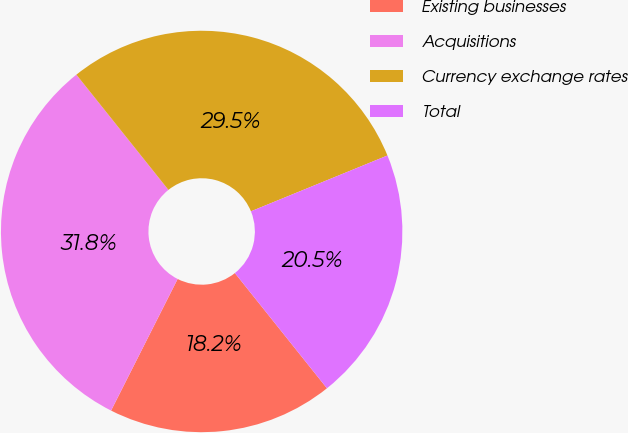<chart> <loc_0><loc_0><loc_500><loc_500><pie_chart><fcel>Existing businesses<fcel>Acquisitions<fcel>Currency exchange rates<fcel>Total<nl><fcel>18.18%<fcel>31.82%<fcel>29.55%<fcel>20.45%<nl></chart> 